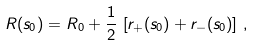<formula> <loc_0><loc_0><loc_500><loc_500>R ( s _ { 0 } ) = R _ { 0 } + \frac { 1 } { 2 } \, \left [ r _ { + } ( s _ { 0 } ) + r _ { - } ( s _ { 0 } ) \right ] \, ,</formula> 